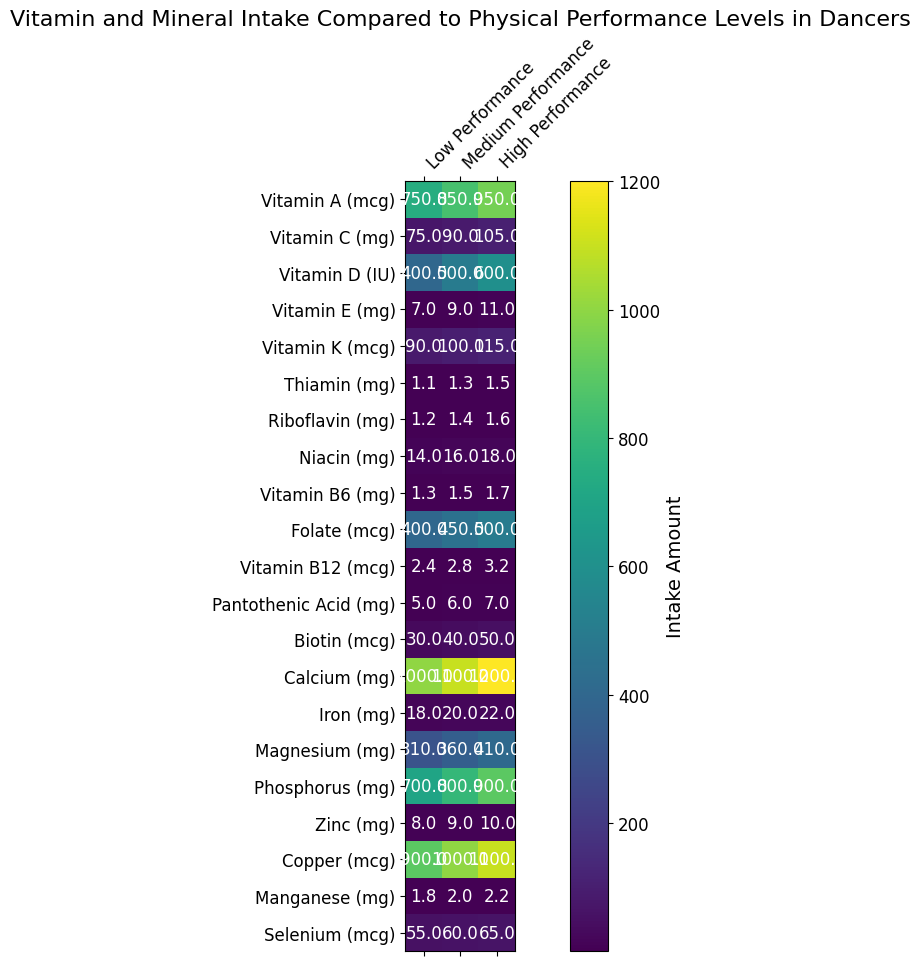What is the difference in Vitamin A intake between Low and High Performance levels? To find the difference, subtract the intake for Low Performance (750 mcg) from the intake for High Performance (950 mcg): 950 - 750.
Answer: 200 Which performance level has the highest intake of Vitamin C? From the heatmap, the intake of Vitamin C for Low, Medium, and High Performance levels are 75 mg, 90 mg, and 105 mg, respectively. The highest value is 105 mg.
Answer: High Performance What is the average Vitamin D intake across all performance levels? Add the Vitamin D intakes for Low, Medium, and High Performance and divide by the number of levels: (400 + 500 + 600) / 3.
Answer: 500 Is the intake of Vitamin B6 for Medium Performance higher than for Low Performance? Compare the intake values: Medium Performance has 1.5 mg of Vitamin B6 and Low Performance has 1.3 mg. 1.5 mg is higher than 1.3 mg.
Answer: Yes Which vitamin or mineral shows the smallest increase in intake from Low to High Performance? Calculate the difference for each vitamin and mineral between Low and High Performance. The smallest difference is for Thiamin: 1.5 - 1.1 = 0.4 mg.
Answer: Thiamin What is the total intake of Biotin across all performance levels? Sum the Biotin intake for Low, Medium, and High Performance: 30 + 40 + 50.
Answer: 120 How does the color intensity for Medium Performance compare to Low Performance for Calcium intake? Visually, the color intensity for Medium Performance (1100 mg) is higher (brighter) than the color for Low Performance (1000 mg).
Answer: Brighter Is the magnesium intake for High Performance lower than phosphorus intake for Medium Performance? Compare the values: High Performance has 410 mg of Magnesium, and Medium Performance has 800 mg of Phosphorus. 410 mg is lower than 800 mg.
Answer: Yes Which mineral shows an equal increase in intake for each step from Low to High Performance levels? Selenium increases by equal amounts from Low (55 mcg) to Medium (60 mcg) to High Performance (65 mcg); the increase is consistently by 5 mcg.
Answer: Selenium 